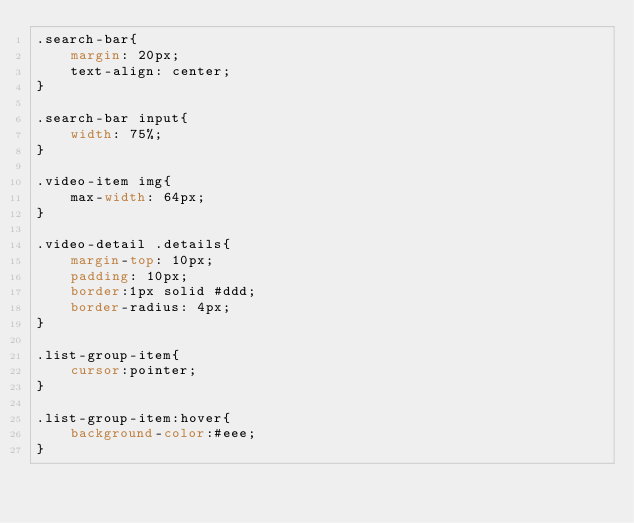Convert code to text. <code><loc_0><loc_0><loc_500><loc_500><_CSS_>.search-bar{
	margin: 20px;
	text-align: center;
}

.search-bar input{
	width: 75%;
}

.video-item img{
	max-width: 64px;
}

.video-detail .details{
	margin-top: 10px;
	padding: 10px;
	border:1px solid #ddd;
	border-radius: 4px;
}

.list-group-item{
	cursor:pointer;
}

.list-group-item:hover{
	background-color:#eee;
}

</code> 